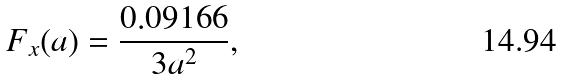<formula> <loc_0><loc_0><loc_500><loc_500>F _ { x } ( a ) = \frac { 0 . 0 9 1 6 6 } { 3 a ^ { 2 } } ,</formula> 